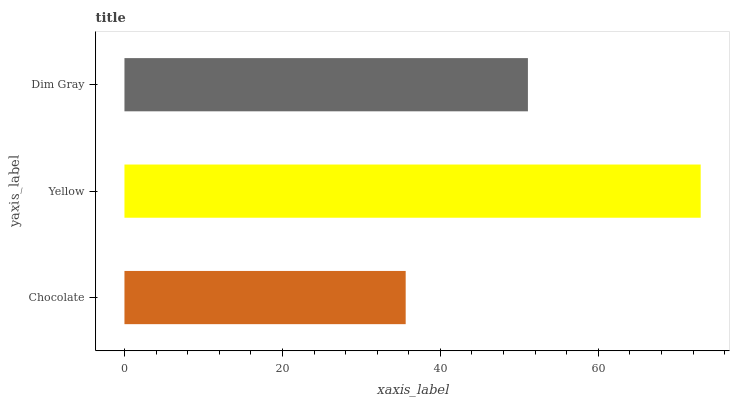Is Chocolate the minimum?
Answer yes or no. Yes. Is Yellow the maximum?
Answer yes or no. Yes. Is Dim Gray the minimum?
Answer yes or no. No. Is Dim Gray the maximum?
Answer yes or no. No. Is Yellow greater than Dim Gray?
Answer yes or no. Yes. Is Dim Gray less than Yellow?
Answer yes or no. Yes. Is Dim Gray greater than Yellow?
Answer yes or no. No. Is Yellow less than Dim Gray?
Answer yes or no. No. Is Dim Gray the high median?
Answer yes or no. Yes. Is Dim Gray the low median?
Answer yes or no. Yes. Is Yellow the high median?
Answer yes or no. No. Is Chocolate the low median?
Answer yes or no. No. 